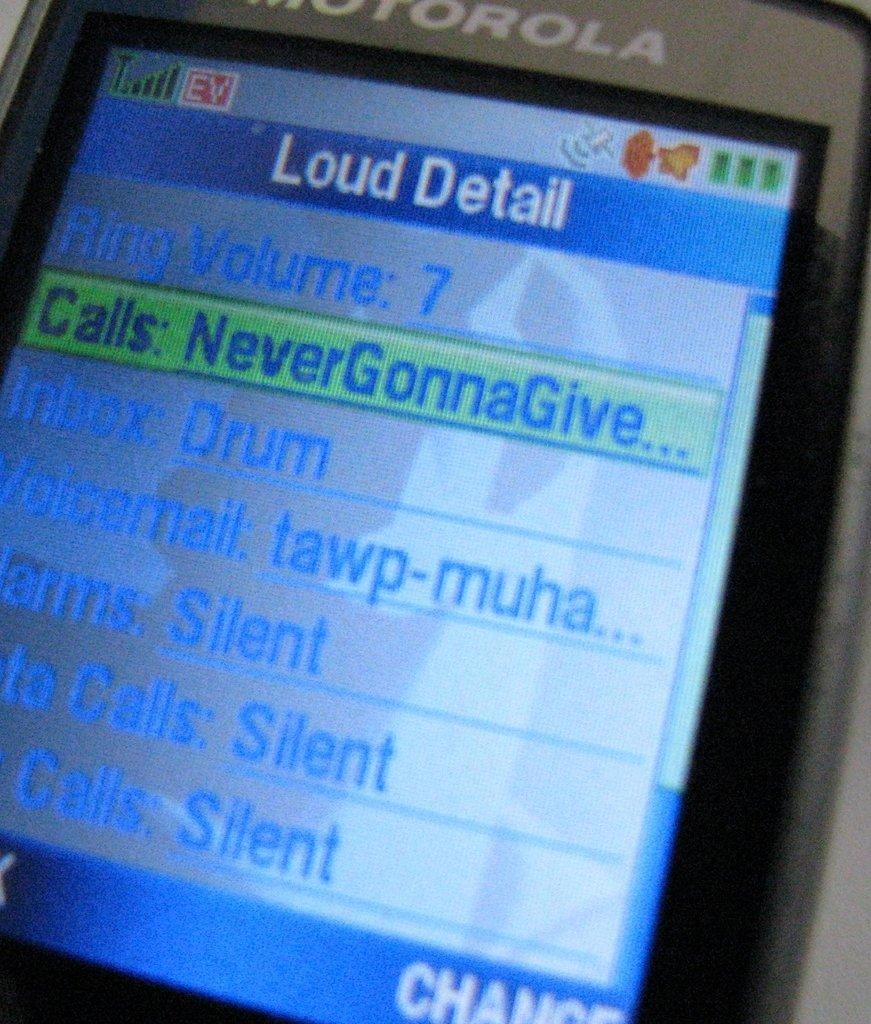What volume is the ring set to?
Offer a terse response. 7. What is the inbox tone set to?
Provide a succinct answer. Drum. 